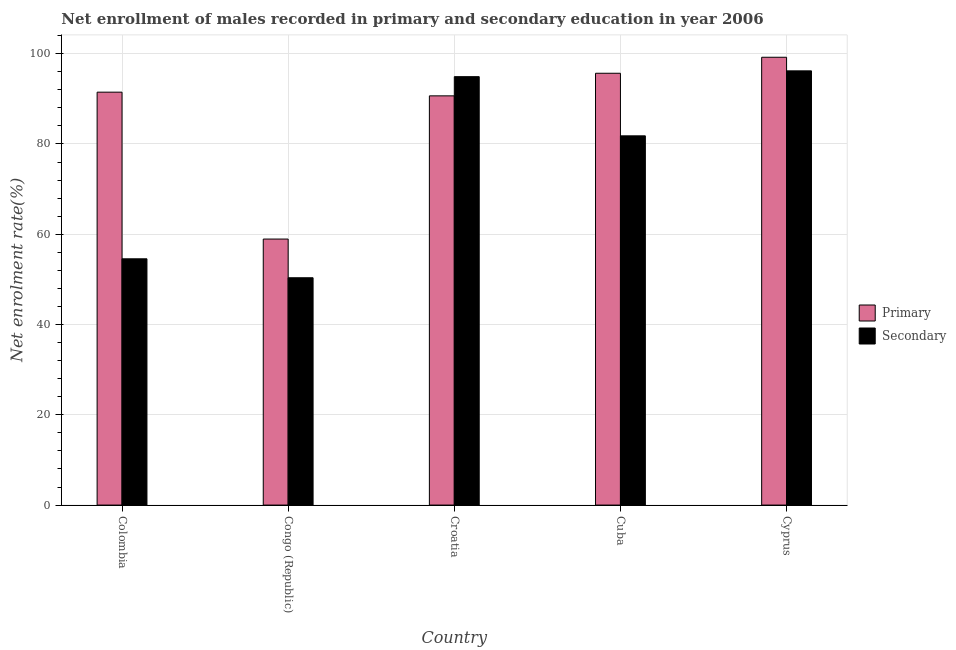How many different coloured bars are there?
Ensure brevity in your answer.  2. Are the number of bars per tick equal to the number of legend labels?
Offer a terse response. Yes. Are the number of bars on each tick of the X-axis equal?
Your answer should be compact. Yes. What is the enrollment rate in primary education in Colombia?
Ensure brevity in your answer.  91.48. Across all countries, what is the maximum enrollment rate in secondary education?
Make the answer very short. 96.2. Across all countries, what is the minimum enrollment rate in primary education?
Keep it short and to the point. 58.94. In which country was the enrollment rate in primary education maximum?
Give a very brief answer. Cyprus. In which country was the enrollment rate in primary education minimum?
Offer a very short reply. Congo (Republic). What is the total enrollment rate in primary education in the graph?
Provide a succinct answer. 435.97. What is the difference between the enrollment rate in secondary education in Croatia and that in Cuba?
Make the answer very short. 13.11. What is the difference between the enrollment rate in secondary education in Congo (Republic) and the enrollment rate in primary education in Colombia?
Your response must be concise. -41.12. What is the average enrollment rate in secondary education per country?
Ensure brevity in your answer.  75.57. What is the difference between the enrollment rate in secondary education and enrollment rate in primary education in Cuba?
Your answer should be compact. -13.87. In how many countries, is the enrollment rate in primary education greater than 44 %?
Your answer should be compact. 5. What is the ratio of the enrollment rate in secondary education in Congo (Republic) to that in Croatia?
Your answer should be very brief. 0.53. What is the difference between the highest and the second highest enrollment rate in primary education?
Your answer should be very brief. 3.54. What is the difference between the highest and the lowest enrollment rate in secondary education?
Your answer should be very brief. 45.84. What does the 1st bar from the left in Congo (Republic) represents?
Your answer should be compact. Primary. What does the 2nd bar from the right in Croatia represents?
Make the answer very short. Primary. How many bars are there?
Offer a terse response. 10. Does the graph contain any zero values?
Your answer should be compact. No. Where does the legend appear in the graph?
Provide a succinct answer. Center right. How many legend labels are there?
Offer a very short reply. 2. How are the legend labels stacked?
Keep it short and to the point. Vertical. What is the title of the graph?
Your answer should be very brief. Net enrollment of males recorded in primary and secondary education in year 2006. Does "Health Care" appear as one of the legend labels in the graph?
Your answer should be very brief. No. What is the label or title of the Y-axis?
Make the answer very short. Net enrolment rate(%). What is the Net enrolment rate(%) of Primary in Colombia?
Your answer should be very brief. 91.48. What is the Net enrolment rate(%) of Secondary in Colombia?
Offer a very short reply. 54.56. What is the Net enrolment rate(%) of Primary in Congo (Republic)?
Provide a short and direct response. 58.94. What is the Net enrolment rate(%) of Secondary in Congo (Republic)?
Provide a short and direct response. 50.36. What is the Net enrolment rate(%) of Primary in Croatia?
Provide a short and direct response. 90.67. What is the Net enrolment rate(%) in Secondary in Croatia?
Your response must be concise. 94.92. What is the Net enrolment rate(%) of Primary in Cuba?
Offer a terse response. 95.67. What is the Net enrolment rate(%) of Secondary in Cuba?
Ensure brevity in your answer.  81.81. What is the Net enrolment rate(%) in Primary in Cyprus?
Offer a very short reply. 99.22. What is the Net enrolment rate(%) of Secondary in Cyprus?
Give a very brief answer. 96.2. Across all countries, what is the maximum Net enrolment rate(%) in Primary?
Give a very brief answer. 99.22. Across all countries, what is the maximum Net enrolment rate(%) of Secondary?
Provide a succinct answer. 96.2. Across all countries, what is the minimum Net enrolment rate(%) of Primary?
Your response must be concise. 58.94. Across all countries, what is the minimum Net enrolment rate(%) of Secondary?
Keep it short and to the point. 50.36. What is the total Net enrolment rate(%) of Primary in the graph?
Make the answer very short. 435.97. What is the total Net enrolment rate(%) of Secondary in the graph?
Keep it short and to the point. 377.85. What is the difference between the Net enrolment rate(%) of Primary in Colombia and that in Congo (Republic)?
Keep it short and to the point. 32.55. What is the difference between the Net enrolment rate(%) in Secondary in Colombia and that in Congo (Republic)?
Offer a very short reply. 4.2. What is the difference between the Net enrolment rate(%) of Primary in Colombia and that in Croatia?
Your answer should be very brief. 0.82. What is the difference between the Net enrolment rate(%) in Secondary in Colombia and that in Croatia?
Your answer should be compact. -40.36. What is the difference between the Net enrolment rate(%) in Primary in Colombia and that in Cuba?
Ensure brevity in your answer.  -4.19. What is the difference between the Net enrolment rate(%) of Secondary in Colombia and that in Cuba?
Offer a very short reply. -27.24. What is the difference between the Net enrolment rate(%) of Primary in Colombia and that in Cyprus?
Provide a short and direct response. -7.73. What is the difference between the Net enrolment rate(%) of Secondary in Colombia and that in Cyprus?
Offer a very short reply. -41.64. What is the difference between the Net enrolment rate(%) in Primary in Congo (Republic) and that in Croatia?
Give a very brief answer. -31.73. What is the difference between the Net enrolment rate(%) in Secondary in Congo (Republic) and that in Croatia?
Your answer should be very brief. -44.55. What is the difference between the Net enrolment rate(%) in Primary in Congo (Republic) and that in Cuba?
Offer a very short reply. -36.73. What is the difference between the Net enrolment rate(%) in Secondary in Congo (Republic) and that in Cuba?
Provide a succinct answer. -31.44. What is the difference between the Net enrolment rate(%) of Primary in Congo (Republic) and that in Cyprus?
Your response must be concise. -40.28. What is the difference between the Net enrolment rate(%) in Secondary in Congo (Republic) and that in Cyprus?
Your response must be concise. -45.84. What is the difference between the Net enrolment rate(%) of Primary in Croatia and that in Cuba?
Provide a short and direct response. -5.01. What is the difference between the Net enrolment rate(%) in Secondary in Croatia and that in Cuba?
Keep it short and to the point. 13.11. What is the difference between the Net enrolment rate(%) of Primary in Croatia and that in Cyprus?
Offer a terse response. -8.55. What is the difference between the Net enrolment rate(%) of Secondary in Croatia and that in Cyprus?
Offer a very short reply. -1.29. What is the difference between the Net enrolment rate(%) of Primary in Cuba and that in Cyprus?
Provide a short and direct response. -3.54. What is the difference between the Net enrolment rate(%) in Secondary in Cuba and that in Cyprus?
Your answer should be compact. -14.4. What is the difference between the Net enrolment rate(%) of Primary in Colombia and the Net enrolment rate(%) of Secondary in Congo (Republic)?
Keep it short and to the point. 41.12. What is the difference between the Net enrolment rate(%) in Primary in Colombia and the Net enrolment rate(%) in Secondary in Croatia?
Offer a terse response. -3.43. What is the difference between the Net enrolment rate(%) in Primary in Colombia and the Net enrolment rate(%) in Secondary in Cuba?
Your answer should be very brief. 9.68. What is the difference between the Net enrolment rate(%) of Primary in Colombia and the Net enrolment rate(%) of Secondary in Cyprus?
Provide a succinct answer. -4.72. What is the difference between the Net enrolment rate(%) of Primary in Congo (Republic) and the Net enrolment rate(%) of Secondary in Croatia?
Keep it short and to the point. -35.98. What is the difference between the Net enrolment rate(%) of Primary in Congo (Republic) and the Net enrolment rate(%) of Secondary in Cuba?
Your answer should be compact. -22.87. What is the difference between the Net enrolment rate(%) of Primary in Congo (Republic) and the Net enrolment rate(%) of Secondary in Cyprus?
Give a very brief answer. -37.27. What is the difference between the Net enrolment rate(%) of Primary in Croatia and the Net enrolment rate(%) of Secondary in Cuba?
Provide a succinct answer. 8.86. What is the difference between the Net enrolment rate(%) of Primary in Croatia and the Net enrolment rate(%) of Secondary in Cyprus?
Keep it short and to the point. -5.54. What is the difference between the Net enrolment rate(%) in Primary in Cuba and the Net enrolment rate(%) in Secondary in Cyprus?
Offer a terse response. -0.53. What is the average Net enrolment rate(%) of Primary per country?
Provide a short and direct response. 87.19. What is the average Net enrolment rate(%) in Secondary per country?
Your answer should be compact. 75.57. What is the difference between the Net enrolment rate(%) in Primary and Net enrolment rate(%) in Secondary in Colombia?
Make the answer very short. 36.92. What is the difference between the Net enrolment rate(%) in Primary and Net enrolment rate(%) in Secondary in Congo (Republic)?
Keep it short and to the point. 8.57. What is the difference between the Net enrolment rate(%) of Primary and Net enrolment rate(%) of Secondary in Croatia?
Ensure brevity in your answer.  -4.25. What is the difference between the Net enrolment rate(%) in Primary and Net enrolment rate(%) in Secondary in Cuba?
Your response must be concise. 13.87. What is the difference between the Net enrolment rate(%) in Primary and Net enrolment rate(%) in Secondary in Cyprus?
Offer a very short reply. 3.01. What is the ratio of the Net enrolment rate(%) in Primary in Colombia to that in Congo (Republic)?
Offer a terse response. 1.55. What is the ratio of the Net enrolment rate(%) of Secondary in Colombia to that in Congo (Republic)?
Offer a terse response. 1.08. What is the ratio of the Net enrolment rate(%) of Secondary in Colombia to that in Croatia?
Ensure brevity in your answer.  0.57. What is the ratio of the Net enrolment rate(%) of Primary in Colombia to that in Cuba?
Ensure brevity in your answer.  0.96. What is the ratio of the Net enrolment rate(%) in Secondary in Colombia to that in Cuba?
Provide a short and direct response. 0.67. What is the ratio of the Net enrolment rate(%) of Primary in Colombia to that in Cyprus?
Ensure brevity in your answer.  0.92. What is the ratio of the Net enrolment rate(%) in Secondary in Colombia to that in Cyprus?
Provide a succinct answer. 0.57. What is the ratio of the Net enrolment rate(%) of Primary in Congo (Republic) to that in Croatia?
Provide a short and direct response. 0.65. What is the ratio of the Net enrolment rate(%) of Secondary in Congo (Republic) to that in Croatia?
Provide a succinct answer. 0.53. What is the ratio of the Net enrolment rate(%) in Primary in Congo (Republic) to that in Cuba?
Your answer should be compact. 0.62. What is the ratio of the Net enrolment rate(%) in Secondary in Congo (Republic) to that in Cuba?
Keep it short and to the point. 0.62. What is the ratio of the Net enrolment rate(%) in Primary in Congo (Republic) to that in Cyprus?
Provide a succinct answer. 0.59. What is the ratio of the Net enrolment rate(%) of Secondary in Congo (Republic) to that in Cyprus?
Provide a short and direct response. 0.52. What is the ratio of the Net enrolment rate(%) in Primary in Croatia to that in Cuba?
Give a very brief answer. 0.95. What is the ratio of the Net enrolment rate(%) of Secondary in Croatia to that in Cuba?
Provide a succinct answer. 1.16. What is the ratio of the Net enrolment rate(%) of Primary in Croatia to that in Cyprus?
Offer a very short reply. 0.91. What is the ratio of the Net enrolment rate(%) in Secondary in Croatia to that in Cyprus?
Give a very brief answer. 0.99. What is the ratio of the Net enrolment rate(%) in Primary in Cuba to that in Cyprus?
Keep it short and to the point. 0.96. What is the ratio of the Net enrolment rate(%) in Secondary in Cuba to that in Cyprus?
Keep it short and to the point. 0.85. What is the difference between the highest and the second highest Net enrolment rate(%) of Primary?
Provide a short and direct response. 3.54. What is the difference between the highest and the second highest Net enrolment rate(%) of Secondary?
Offer a terse response. 1.29. What is the difference between the highest and the lowest Net enrolment rate(%) of Primary?
Make the answer very short. 40.28. What is the difference between the highest and the lowest Net enrolment rate(%) of Secondary?
Provide a short and direct response. 45.84. 